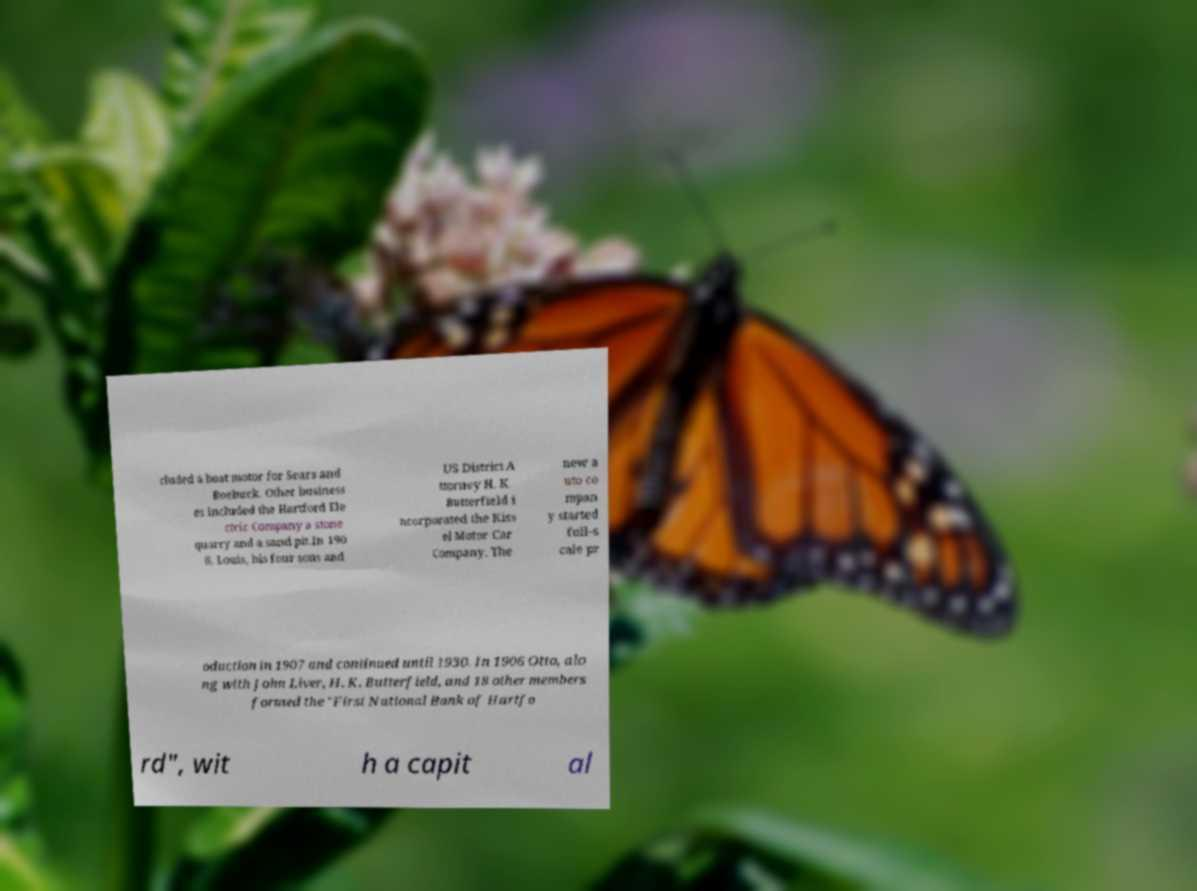What messages or text are displayed in this image? I need them in a readable, typed format. cluded a boat motor for Sears and Roebuck. Other business es included the Hartford Ele ctric Company a stone quarry and a sand pit.In 190 6, Louis, his four sons and US District A ttorney H. K. Butterfield i ncorporated the Kiss el Motor Car Company. The new a uto co mpan y started full-s cale pr oduction in 1907 and continued until 1930. In 1906 Otto, alo ng with John Liver, H. K. Butterfield, and 18 other members formed the "First National Bank of Hartfo rd", wit h a capit al 